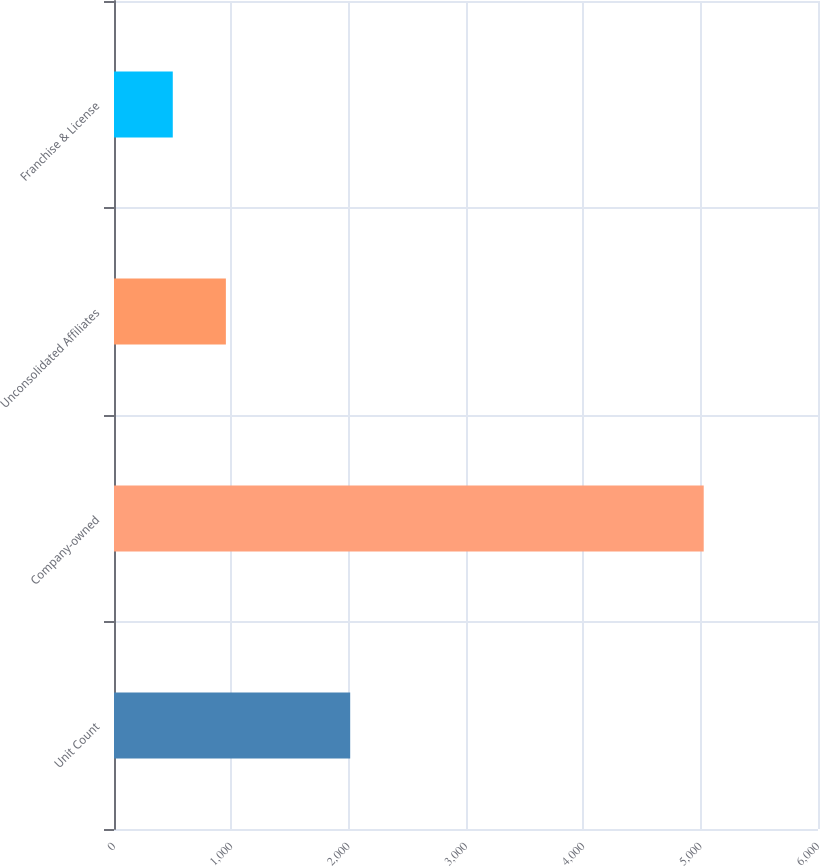Convert chart. <chart><loc_0><loc_0><loc_500><loc_500><bar_chart><fcel>Unit Count<fcel>Company-owned<fcel>Unconsolidated Affiliates<fcel>Franchise & License<nl><fcel>2013<fcel>5026<fcel>953.5<fcel>501<nl></chart> 